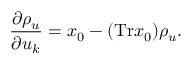<formula> <loc_0><loc_0><loc_500><loc_500>\frac { \partial \rho _ { u } } { \partial u _ { k } } = x _ { 0 } - ( T r x _ { 0 } ) \rho _ { u } .</formula> 